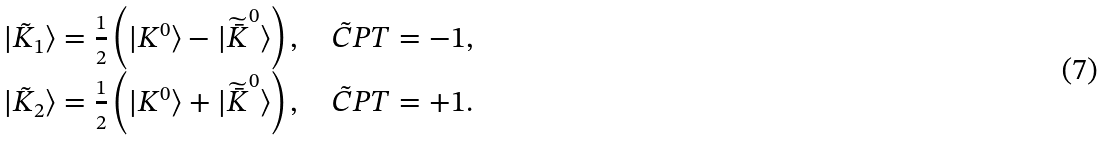Convert formula to latex. <formula><loc_0><loc_0><loc_500><loc_500>\begin{array} { c } | \tilde { K } _ { 1 } \rangle = \frac { 1 } { 2 } \left ( | K ^ { 0 } \rangle - | \widetilde { \bar { K } } ^ { 0 } \rangle \right ) , \quad \tilde { C } P T = - 1 , \\ | \tilde { K } _ { 2 } \rangle = \frac { 1 } { 2 } \left ( | K ^ { 0 } \rangle + | \widetilde { \bar { K } } ^ { 0 } \rangle \right ) , \quad \tilde { C } P T = + 1 . \end{array}</formula> 